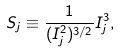<formula> <loc_0><loc_0><loc_500><loc_500>S _ { j } \equiv \frac { 1 } { ( I _ { j } ^ { 2 } ) ^ { 3 / 2 } } I ^ { 3 } _ { j } ,</formula> 